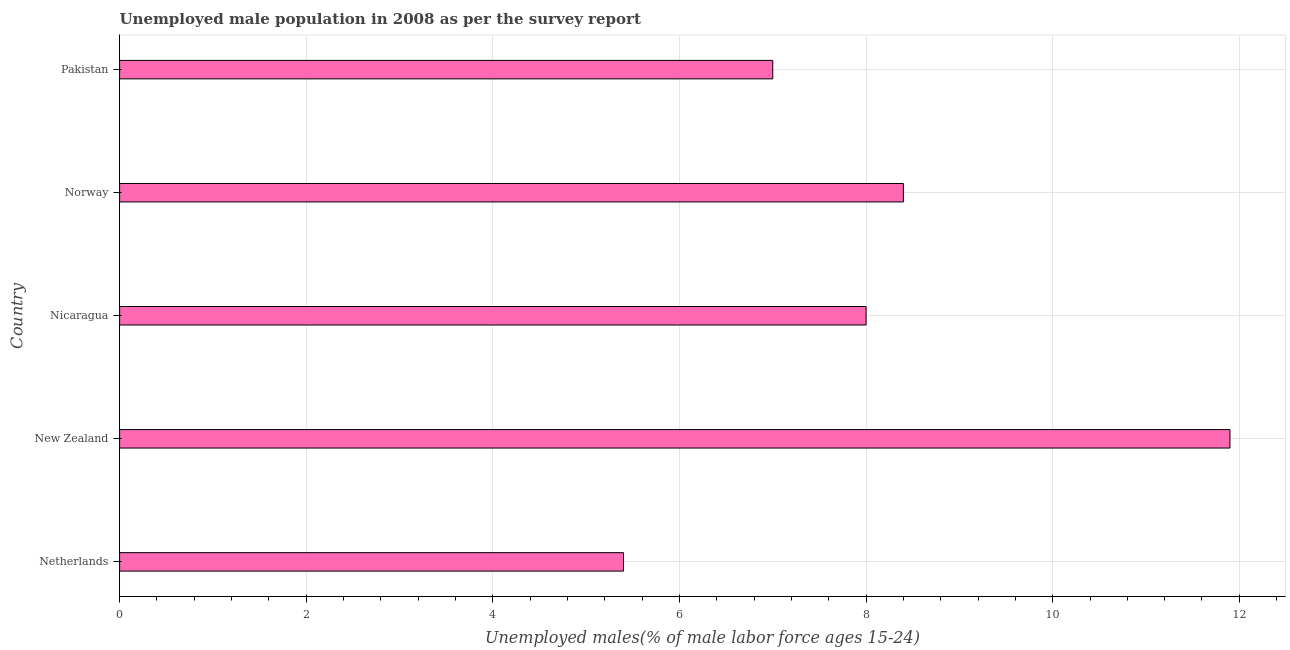What is the title of the graph?
Provide a short and direct response. Unemployed male population in 2008 as per the survey report. What is the label or title of the X-axis?
Ensure brevity in your answer.  Unemployed males(% of male labor force ages 15-24). What is the unemployed male youth in New Zealand?
Your answer should be very brief. 11.9. Across all countries, what is the maximum unemployed male youth?
Offer a terse response. 11.9. Across all countries, what is the minimum unemployed male youth?
Make the answer very short. 5.4. In which country was the unemployed male youth maximum?
Keep it short and to the point. New Zealand. In which country was the unemployed male youth minimum?
Provide a succinct answer. Netherlands. What is the sum of the unemployed male youth?
Provide a succinct answer. 40.7. What is the average unemployed male youth per country?
Ensure brevity in your answer.  8.14. What is the ratio of the unemployed male youth in New Zealand to that in Norway?
Your answer should be compact. 1.42. Is the unemployed male youth in New Zealand less than that in Norway?
Keep it short and to the point. No. Is the difference between the unemployed male youth in Netherlands and Pakistan greater than the difference between any two countries?
Keep it short and to the point. No. Is the sum of the unemployed male youth in Netherlands and Nicaragua greater than the maximum unemployed male youth across all countries?
Your answer should be compact. Yes. What is the difference between the highest and the lowest unemployed male youth?
Provide a short and direct response. 6.5. In how many countries, is the unemployed male youth greater than the average unemployed male youth taken over all countries?
Make the answer very short. 2. Are the values on the major ticks of X-axis written in scientific E-notation?
Offer a terse response. No. What is the Unemployed males(% of male labor force ages 15-24) in Netherlands?
Offer a terse response. 5.4. What is the Unemployed males(% of male labor force ages 15-24) of New Zealand?
Provide a short and direct response. 11.9. What is the Unemployed males(% of male labor force ages 15-24) in Nicaragua?
Make the answer very short. 8. What is the Unemployed males(% of male labor force ages 15-24) of Norway?
Provide a succinct answer. 8.4. What is the difference between the Unemployed males(% of male labor force ages 15-24) in Netherlands and New Zealand?
Offer a terse response. -6.5. What is the difference between the Unemployed males(% of male labor force ages 15-24) in Netherlands and Norway?
Keep it short and to the point. -3. What is the difference between the Unemployed males(% of male labor force ages 15-24) in New Zealand and Nicaragua?
Ensure brevity in your answer.  3.9. What is the difference between the Unemployed males(% of male labor force ages 15-24) in New Zealand and Norway?
Your answer should be very brief. 3.5. What is the difference between the Unemployed males(% of male labor force ages 15-24) in New Zealand and Pakistan?
Your answer should be compact. 4.9. What is the difference between the Unemployed males(% of male labor force ages 15-24) in Nicaragua and Pakistan?
Offer a very short reply. 1. What is the ratio of the Unemployed males(% of male labor force ages 15-24) in Netherlands to that in New Zealand?
Provide a succinct answer. 0.45. What is the ratio of the Unemployed males(% of male labor force ages 15-24) in Netherlands to that in Nicaragua?
Keep it short and to the point. 0.68. What is the ratio of the Unemployed males(% of male labor force ages 15-24) in Netherlands to that in Norway?
Offer a very short reply. 0.64. What is the ratio of the Unemployed males(% of male labor force ages 15-24) in Netherlands to that in Pakistan?
Your response must be concise. 0.77. What is the ratio of the Unemployed males(% of male labor force ages 15-24) in New Zealand to that in Nicaragua?
Give a very brief answer. 1.49. What is the ratio of the Unemployed males(% of male labor force ages 15-24) in New Zealand to that in Norway?
Ensure brevity in your answer.  1.42. What is the ratio of the Unemployed males(% of male labor force ages 15-24) in New Zealand to that in Pakistan?
Keep it short and to the point. 1.7. What is the ratio of the Unemployed males(% of male labor force ages 15-24) in Nicaragua to that in Pakistan?
Offer a terse response. 1.14. What is the ratio of the Unemployed males(% of male labor force ages 15-24) in Norway to that in Pakistan?
Your answer should be very brief. 1.2. 